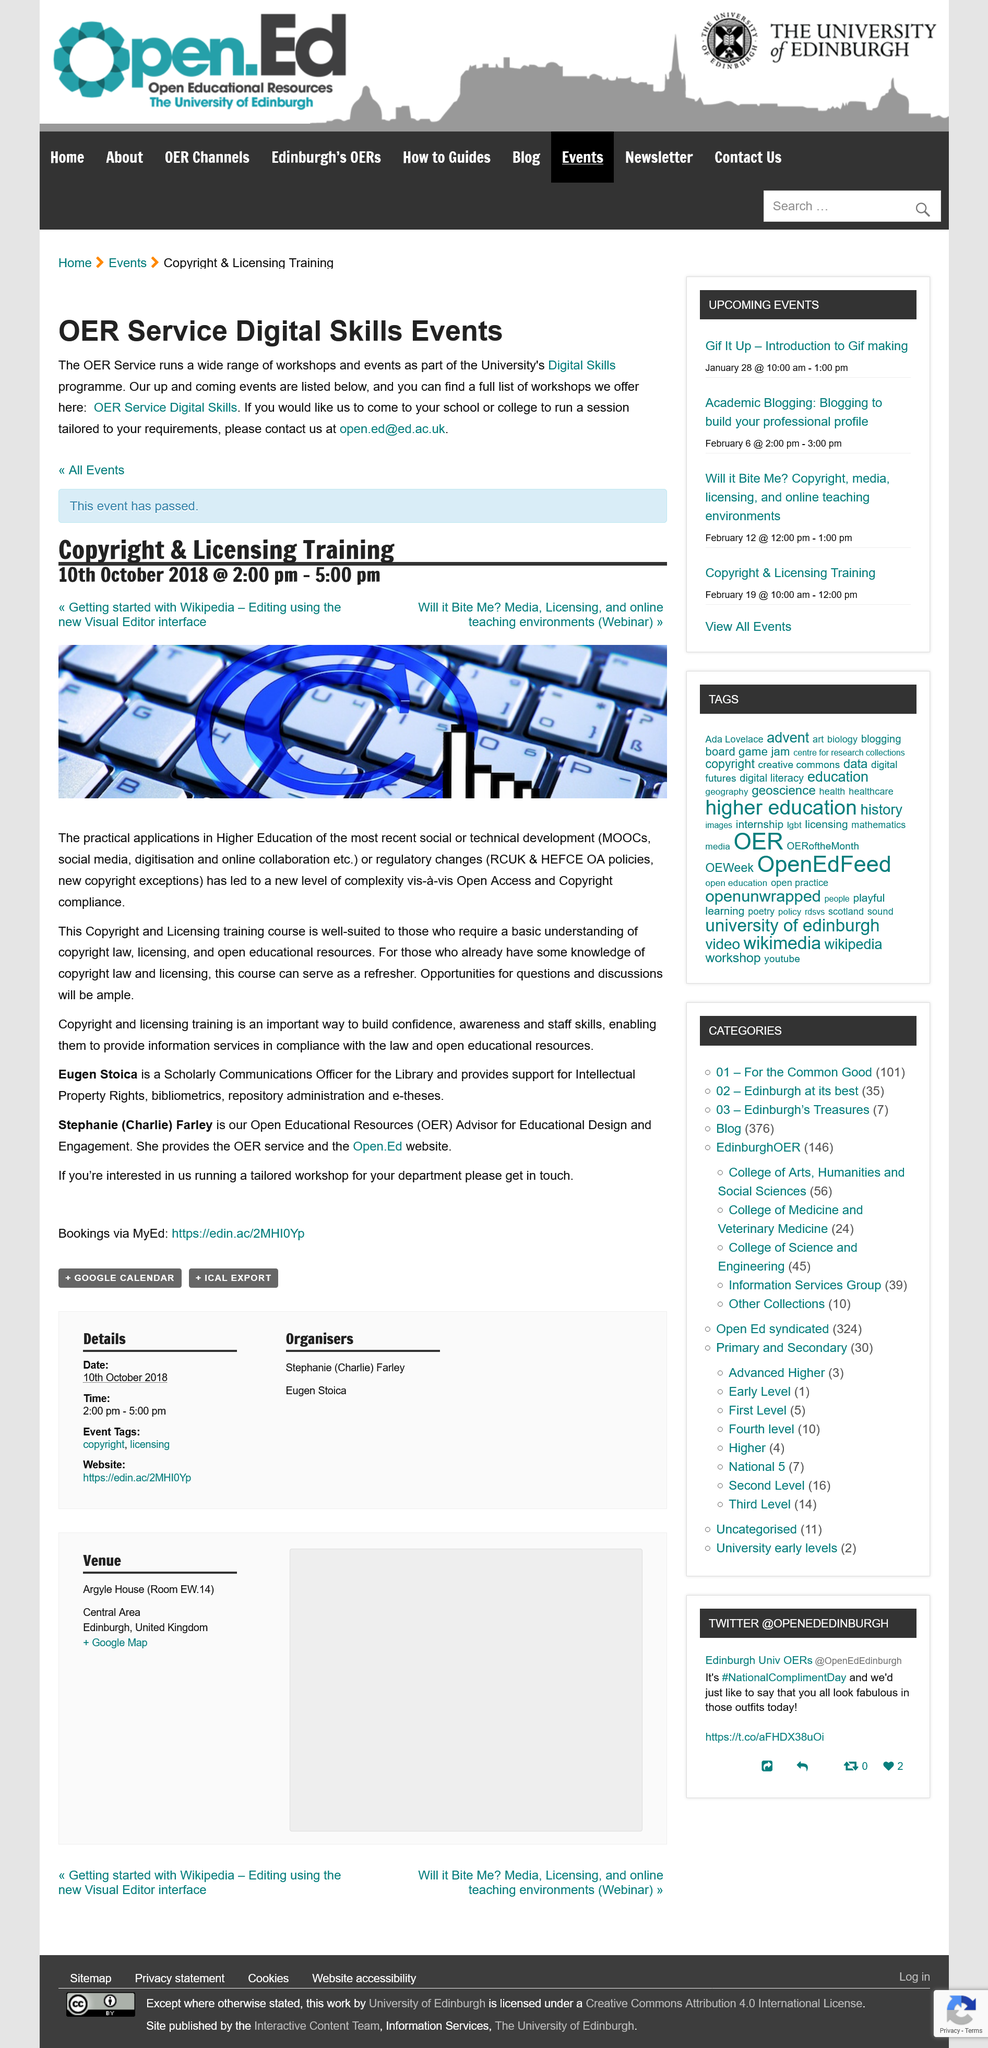List a handful of essential elements in this visual. The event took place on October 10th, 2018. The duration of the event was three hours. The event is a training on copyright and licensing. 